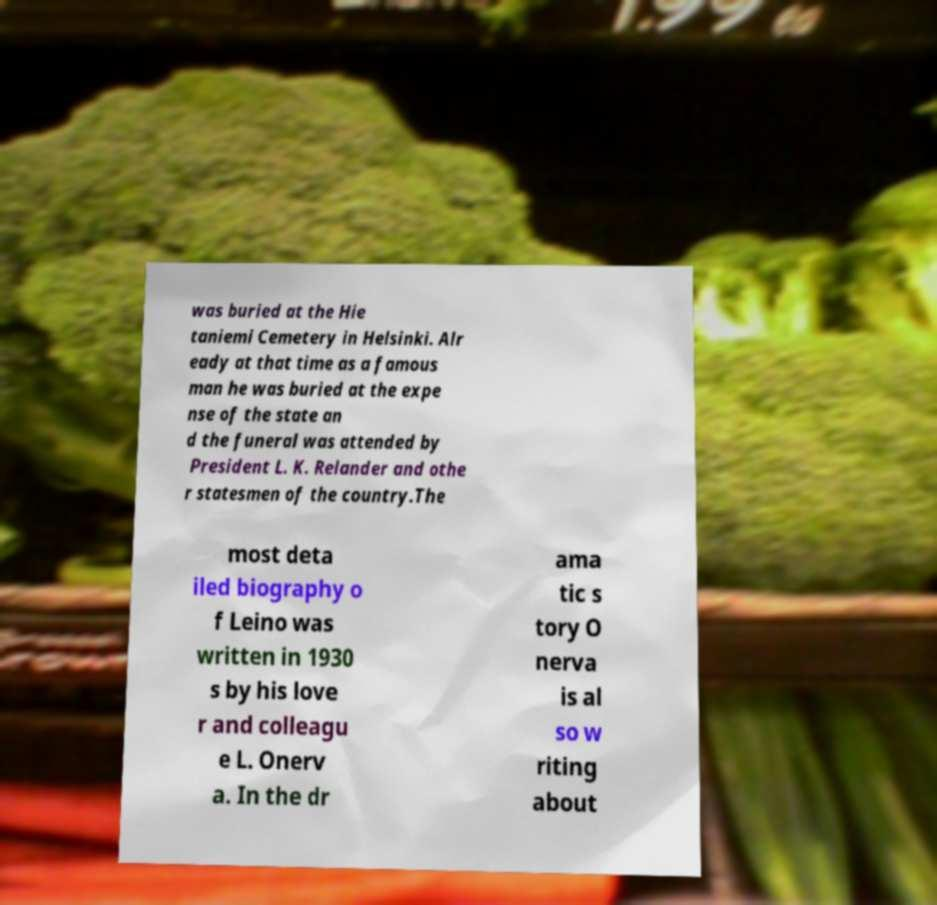Can you accurately transcribe the text from the provided image for me? was buried at the Hie taniemi Cemetery in Helsinki. Alr eady at that time as a famous man he was buried at the expe nse of the state an d the funeral was attended by President L. K. Relander and othe r statesmen of the country.The most deta iled biography o f Leino was written in 1930 s by his love r and colleagu e L. Onerv a. In the dr ama tic s tory O nerva is al so w riting about 